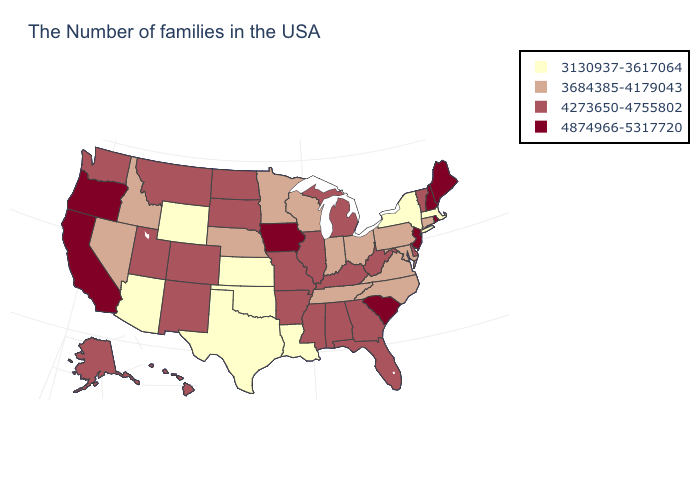What is the value of California?
Answer briefly. 4874966-5317720. What is the value of Alaska?
Short answer required. 4273650-4755802. Does the map have missing data?
Short answer required. No. Name the states that have a value in the range 4874966-5317720?
Concise answer only. Maine, Rhode Island, New Hampshire, New Jersey, South Carolina, Iowa, California, Oregon. Name the states that have a value in the range 4273650-4755802?
Short answer required. Vermont, Delaware, West Virginia, Florida, Georgia, Michigan, Kentucky, Alabama, Illinois, Mississippi, Missouri, Arkansas, South Dakota, North Dakota, Colorado, New Mexico, Utah, Montana, Washington, Alaska, Hawaii. Does the first symbol in the legend represent the smallest category?
Keep it brief. Yes. Does the first symbol in the legend represent the smallest category?
Keep it brief. Yes. What is the value of Minnesota?
Keep it brief. 3684385-4179043. Does Arkansas have a lower value than Oregon?
Write a very short answer. Yes. How many symbols are there in the legend?
Answer briefly. 4. Does the first symbol in the legend represent the smallest category?
Answer briefly. Yes. What is the value of Missouri?
Give a very brief answer. 4273650-4755802. Name the states that have a value in the range 4874966-5317720?
Give a very brief answer. Maine, Rhode Island, New Hampshire, New Jersey, South Carolina, Iowa, California, Oregon. Among the states that border Indiana , which have the highest value?
Answer briefly. Michigan, Kentucky, Illinois. 